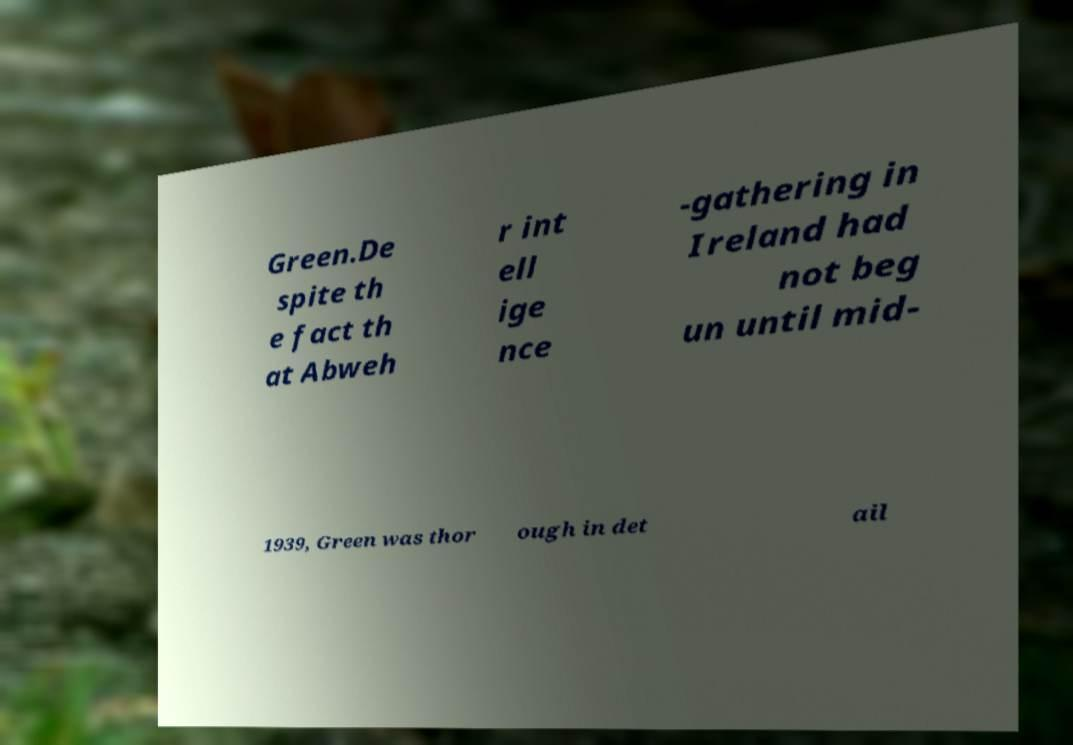Please read and relay the text visible in this image. What does it say? Green.De spite th e fact th at Abweh r int ell ige nce -gathering in Ireland had not beg un until mid- 1939, Green was thor ough in det ail 